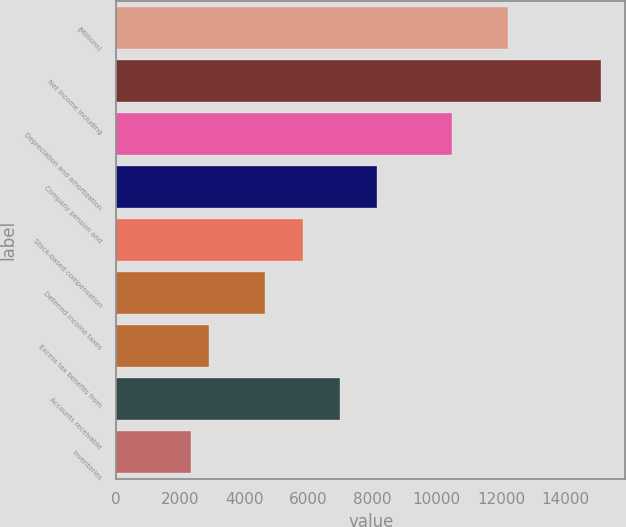Convert chart. <chart><loc_0><loc_0><loc_500><loc_500><bar_chart><fcel>(Millions)<fcel>Net income including<fcel>Depreciation and amortization<fcel>Company pension and<fcel>Stock-based compensation<fcel>Deferred income taxes<fcel>Excess tax benefits from<fcel>Accounts receivable<fcel>Inventories<nl><fcel>12213.5<fcel>15121<fcel>10469<fcel>8143<fcel>5817<fcel>4654<fcel>2909.5<fcel>6980<fcel>2328<nl></chart> 